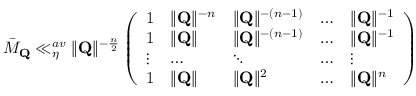Convert formula to latex. <formula><loc_0><loc_0><loc_500><loc_500>\bar { M } _ { Q } \ll _ { \eta } ^ { a v } \| Q \| ^ { - \frac { n } { 2 } } \left ( \begin{array} { l l l l l } { 1 } & { \| Q \| ^ { - n } } & { \| Q \| ^ { - ( n - 1 ) } } & { \dots } & { \| Q \| ^ { - 1 } } \\ { 1 } & { \| Q \| } & { \| Q \| ^ { - ( n - 1 ) } } & { \dots } & { \| Q \| ^ { - 1 } } \\ { \vdots } & { \dots } & { \ddots } & { \dots } & { \vdots } \\ { 1 } & { \| Q \| } & { \| Q \| ^ { 2 } } & { \dots } & { \| Q \| ^ { n } } \end{array} \right )</formula> 